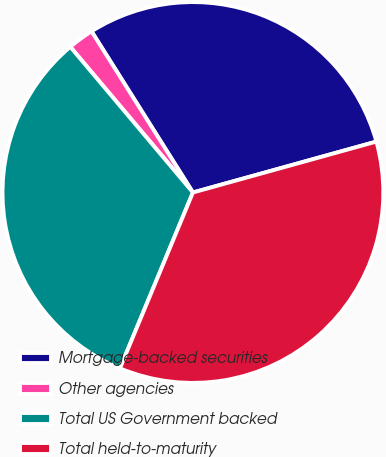Convert chart to OTSL. <chart><loc_0><loc_0><loc_500><loc_500><pie_chart><fcel>Mortgage-backed securities<fcel>Other agencies<fcel>Total US Government backed<fcel>Total held-to-maturity<nl><fcel>29.63%<fcel>2.2%<fcel>32.6%<fcel>35.57%<nl></chart> 